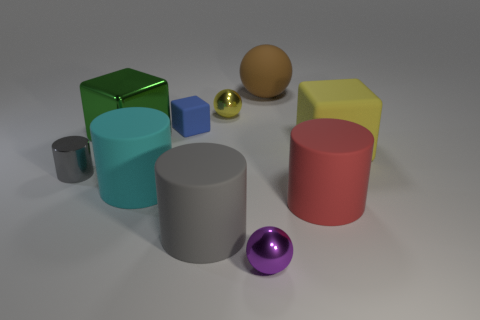Is the small sphere that is behind the large yellow block made of the same material as the ball that is to the right of the small purple metallic sphere?
Your answer should be very brief. No. Are there fewer yellow matte cubes behind the big metallic cube than blue cylinders?
Give a very brief answer. No. There is a rubber cube to the left of the large brown thing; what number of big cylinders are right of it?
Your response must be concise. 2. There is a object that is in front of the metal cube and left of the cyan cylinder; what size is it?
Give a very brief answer. Small. Is there any other thing that has the same material as the green object?
Offer a very short reply. Yes. Do the purple sphere and the large block to the left of the tiny purple ball have the same material?
Your response must be concise. Yes. Are there fewer big blocks to the left of the small blue thing than large green metal objects that are to the right of the large gray matte thing?
Your response must be concise. No. There is a yellow object on the right side of the big brown matte thing; what is it made of?
Your answer should be compact. Rubber. There is a big rubber object that is in front of the metal cylinder and to the right of the purple metallic sphere; what color is it?
Provide a succinct answer. Red. How many other things are there of the same color as the big metallic thing?
Your response must be concise. 0. 